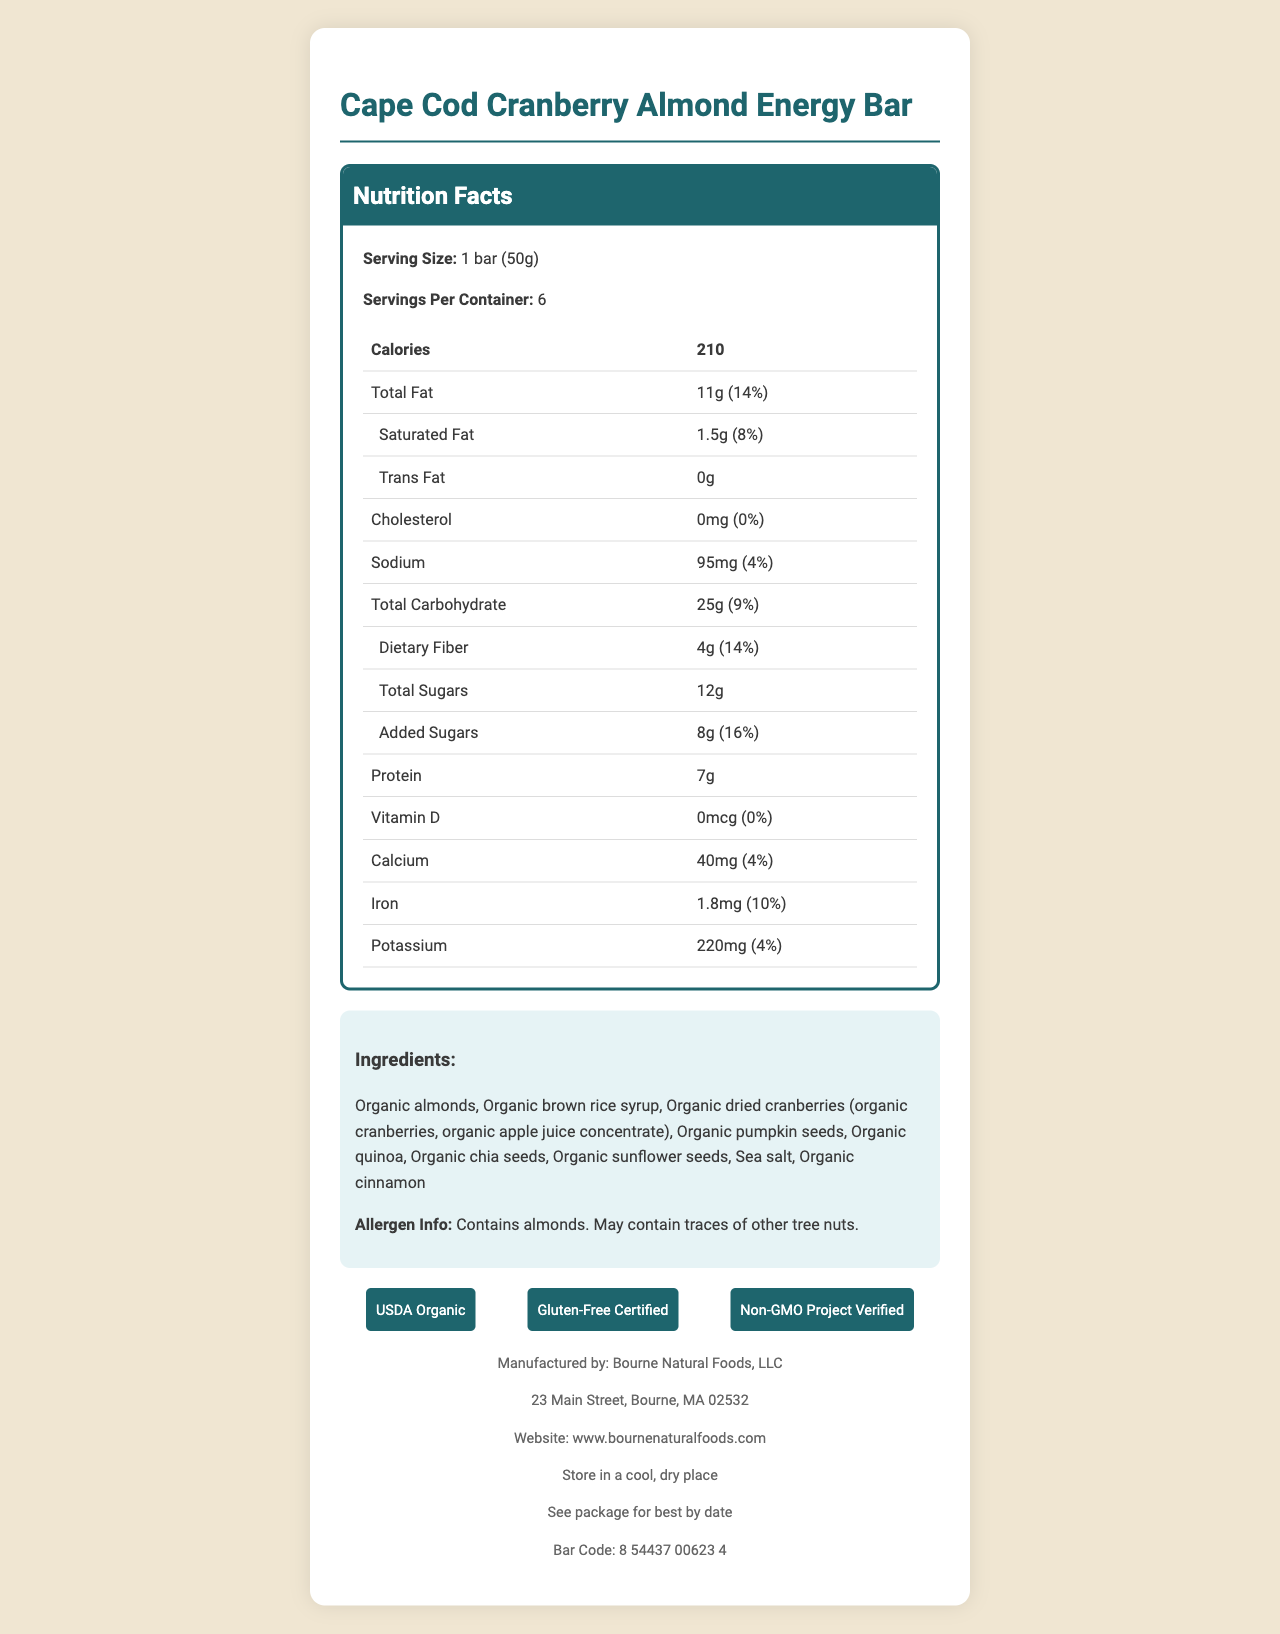what is the serving size? The serving size is explicitly mentioned as "1 bar (50g)" in the Nutrition Facts section.
Answer: 1 bar (50g) how many calories are there per serving? The document specifies that there are 210 calories per serving.
Answer: 210 what is the amount of protein in one bar? The Nutrition Facts state that there are 7g of protein per bar.
Answer: 7g what is the daily value percentage for calcium? The daily value for calcium is listed as 4% in the Nutrition Facts.
Answer: 4% how much dietary fiber is in one bar? The document indicates that one bar contains 4g of dietary fiber.
Answer: 4g which ingredient is not organic? A. Almonds B. Brown rice syrup C. Sea salt D. Dried cranberries All the other ingredients explicitly state they are organic, while sea salt does not have the organic label.
Answer: C. Sea salt how much added sugars does this product contain? The amount of added sugars is given as 8g in the Nutrition Facts.
Answer: 8g does this product contain gluten? The product is labeled as "Gluten-Free Certified" in the certifications section.
Answer: No what are the main allergens present in this energy bar? The allergen information explicitly states that the product contains almonds and may contain traces of other tree nuts.
Answer: Contains almonds. May contain traces of other tree nuts. who is the manufacturer of this product? The manufacturer is listed as Bourne Natural Foods, LLC in the footer of the document.
Answer: Bourne Natural Foods, LLC how should this product be stored? The storage instructions in the footer specify that it should be stored in a cool, dry place.
Answer: Store in a cool, dry place what percentage of the Daily Value does the saturated fat constitute? A. 4% B. 8% C. 14% D. 16% The nutrition label states that the saturated fat constitutes 8% of the daily value.
Answer: B. 8% what certifications does the product have? The certifications for USDA Organic, Gluten-Free Certified, and Non-GMO Project Verified are found in the certifications section.
Answer: USDA Organic, Gluten-Free Certified, Non-GMO Project Verified is there any cholesterol in this product? The document states that the cholesterol amount is 0mg and 0% Daily Value, indicating there is no cholesterol.
Answer: No what is the main concept of the document? The document effectively details the nutritional content, ingredient list, certifications, allergen warnings, and storage instructions for the energy bar, focusing on its health benefits and Cape Cod-inspired flavors.
Answer: The document provides detailed nutritional information, ingredients, allergen info, certifications, and manufacturer details for the Cape Cod Cranberry Almond Energy Bar, emphasizing its organic, gluten-free ingredients and certifications. how many grams of total sugars are present in one bar? The total sugars in one bar are listed as 12g in the Nutrition Facts.
Answer: 12g what is the website of the manufacturer? The manufacturer's website is listed in the footer section.
Answer: www.bournenaturalfoods.com what is the bar code number for this product? The bar code number is explicitly shown in the footer of the document.
Answer: 8 54437 00623 4 what is the address of the manufacturer? The manufacturer's address is mentioned in the footer section.
Answer: 23 Main Street, Bourne, MA 02532 what is the source of dried cranberries in the ingredients list? The source of dried cranberries is detailed in parenthesis within the ingredients list.
Answer: Organic cranberries, organic apple juice concentrate which nutrient has the highest daily value percentage? Among the listed nutrients, added sugars have the highest daily value percentage at 16%.
Answer: Added sugars (16%) how much sodium is in one bar? The sodium content per bar is 95mg as provided in the Nutrition Facts.
Answer: 95mg does this product contain any animal-derived ingredients? The document does not specify whether the ingredients are fully plant-based or if any of the organic certifications cover animal byproducts, so this cannot be determined based on the information provided.
Answer: Cannot be determined 